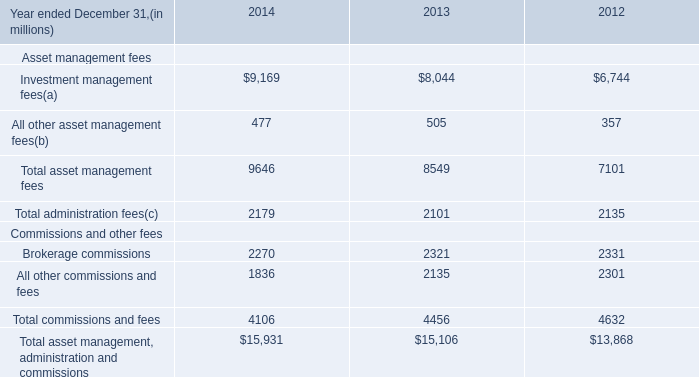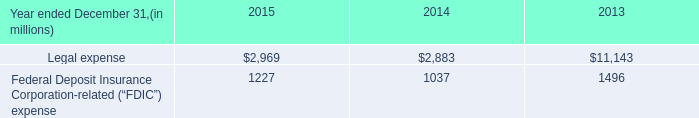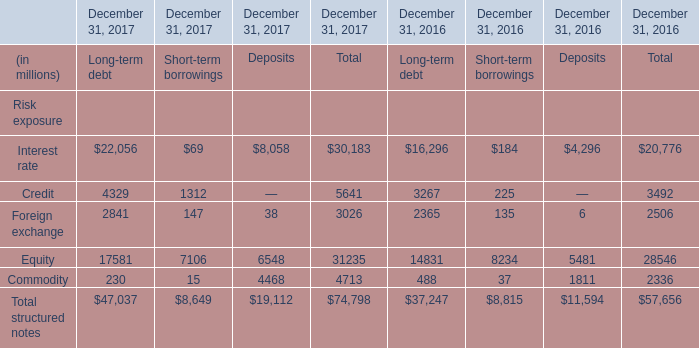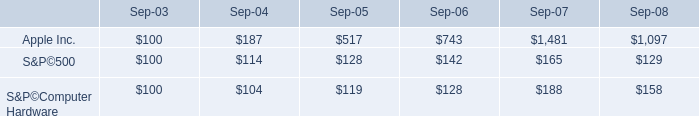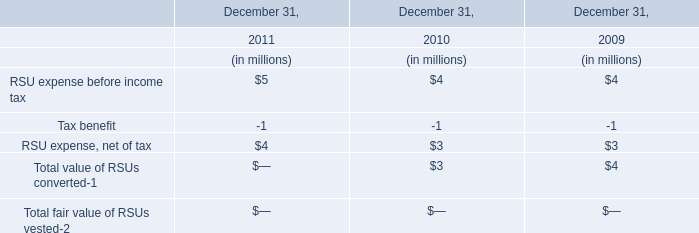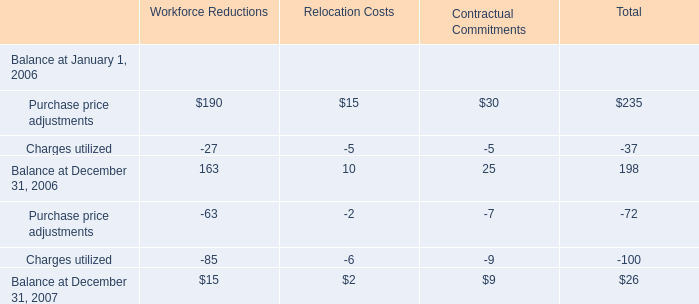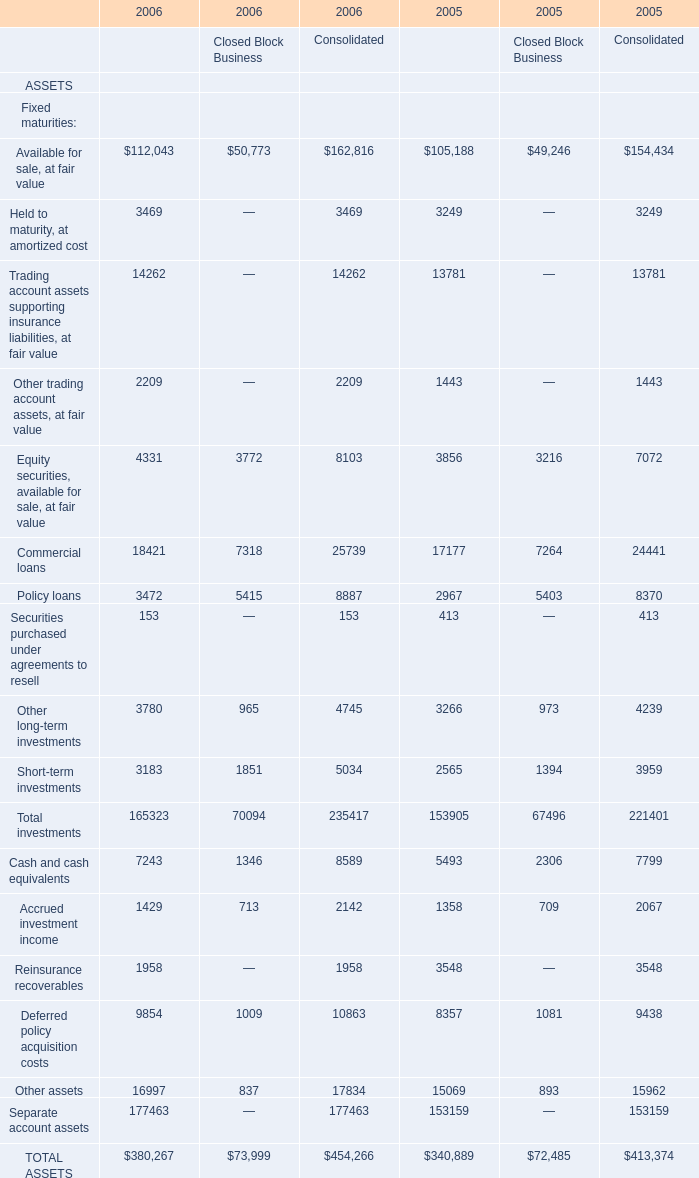What is the sum of Equity of Deposits in 2016 and Total asset management fees in 2013? (in million) 
Computations: (5481 + 8549)
Answer: 14030.0. 